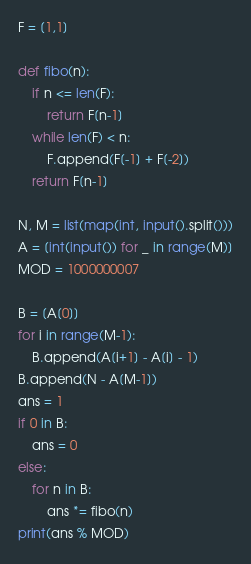<code> <loc_0><loc_0><loc_500><loc_500><_Python_>F = [1,1]

def fibo(n):
    if n <= len(F):
        return F[n-1]
    while len(F) < n:
        F.append(F[-1] + F[-2])
    return F[n-1]

N, M = list(map(int, input().split()))
A = [int(input()) for _ in range(M)]
MOD = 1000000007

B = [A[0]]
for i in range(M-1):
    B.append(A[i+1] - A[i] - 1)
B.append(N - A[M-1])
ans = 1
if 0 in B:
    ans = 0
else:
    for n in B:
        ans *= fibo(n)
print(ans % MOD)
</code> 